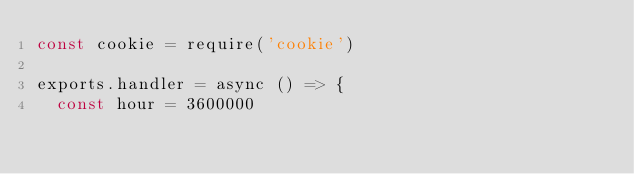Convert code to text. <code><loc_0><loc_0><loc_500><loc_500><_JavaScript_>const cookie = require('cookie')

exports.handler = async () => {
  const hour = 3600000</code> 